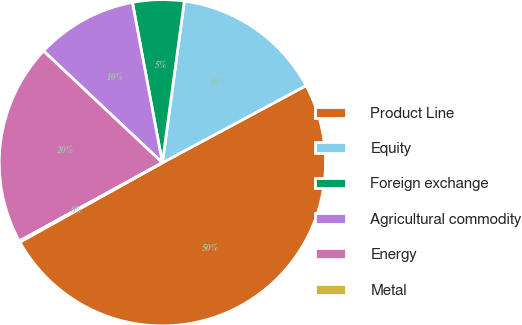Convert chart. <chart><loc_0><loc_0><loc_500><loc_500><pie_chart><fcel>Product Line<fcel>Equity<fcel>Foreign exchange<fcel>Agricultural commodity<fcel>Energy<fcel>Metal<nl><fcel>49.75%<fcel>15.01%<fcel>5.09%<fcel>10.05%<fcel>19.98%<fcel>0.12%<nl></chart> 